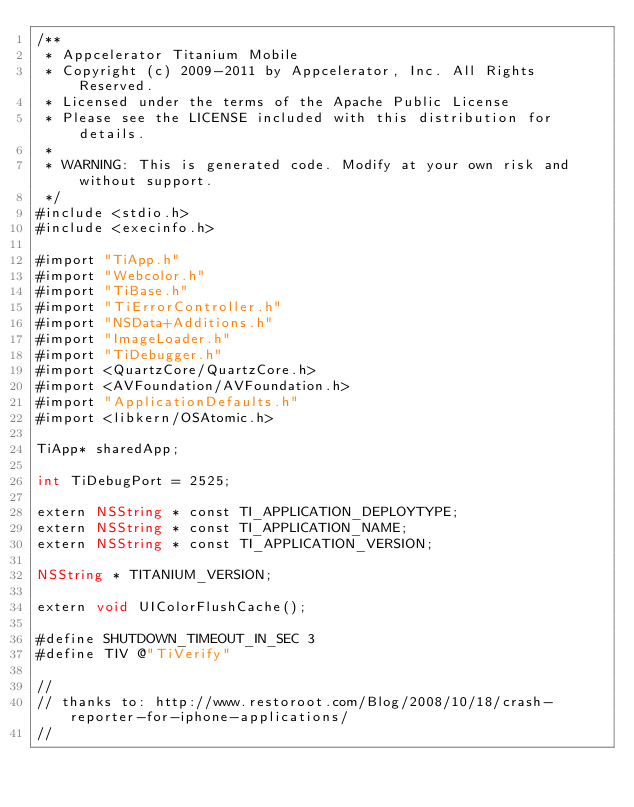<code> <loc_0><loc_0><loc_500><loc_500><_ObjectiveC_>/**
 * Appcelerator Titanium Mobile
 * Copyright (c) 2009-2011 by Appcelerator, Inc. All Rights Reserved.
 * Licensed under the terms of the Apache Public License
 * Please see the LICENSE included with this distribution for details.
 * 
 * WARNING: This is generated code. Modify at your own risk and without support.
 */
#include <stdio.h>
#include <execinfo.h>

#import "TiApp.h"
#import "Webcolor.h"
#import "TiBase.h"
#import "TiErrorController.h"
#import "NSData+Additions.h"
#import "ImageLoader.h"
#import "TiDebugger.h"
#import <QuartzCore/QuartzCore.h>
#import <AVFoundation/AVFoundation.h>
#import "ApplicationDefaults.h"
#import <libkern/OSAtomic.h>

TiApp* sharedApp;

int TiDebugPort = 2525;

extern NSString * const TI_APPLICATION_DEPLOYTYPE;
extern NSString * const TI_APPLICATION_NAME;
extern NSString * const TI_APPLICATION_VERSION;

NSString * TITANIUM_VERSION;

extern void UIColorFlushCache();

#define SHUTDOWN_TIMEOUT_IN_SEC	3
#define TIV @"TiVerify"

//
// thanks to: http://www.restoroot.com/Blog/2008/10/18/crash-reporter-for-iphone-applications/
//</code> 